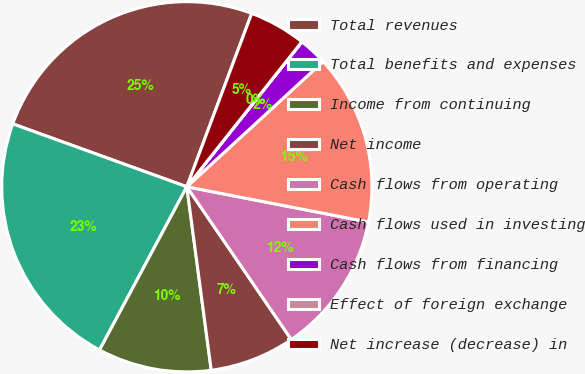Convert chart to OTSL. <chart><loc_0><loc_0><loc_500><loc_500><pie_chart><fcel>Total revenues<fcel>Total benefits and expenses<fcel>Income from continuing<fcel>Net income<fcel>Cash flows from operating<fcel>Cash flows used in investing<fcel>Cash flows from financing<fcel>Effect of foreign exchange<fcel>Net increase (decrease) in<nl><fcel>25.18%<fcel>22.7%<fcel>9.92%<fcel>7.44%<fcel>12.4%<fcel>14.88%<fcel>2.49%<fcel>0.01%<fcel>4.97%<nl></chart> 